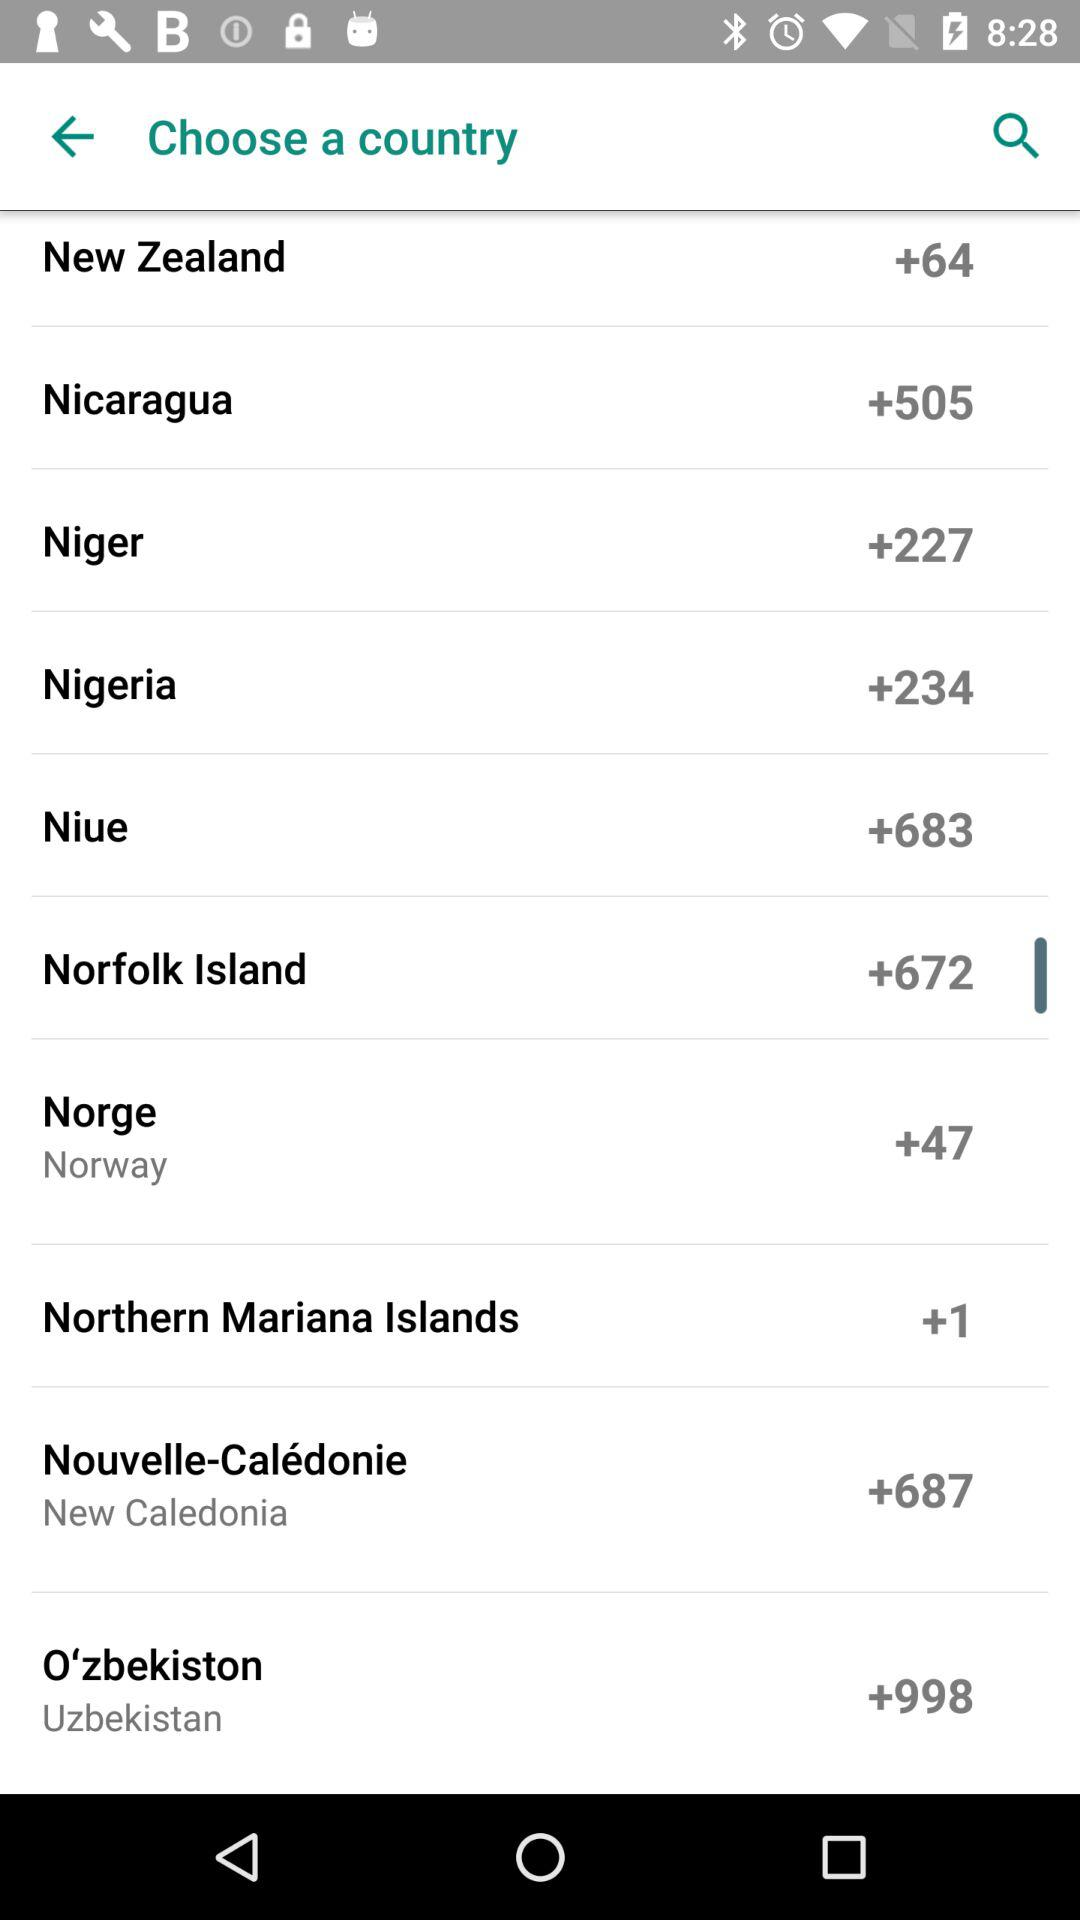What is the country code for Nicaragua? The country code for Nicaragua is +505. 